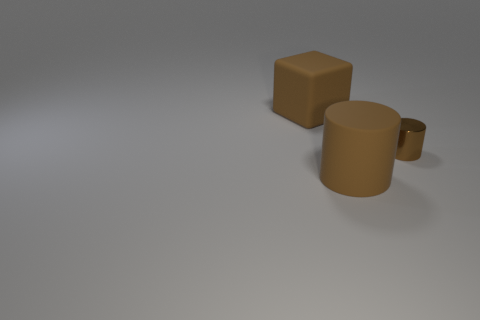Add 1 big cylinders. How many objects exist? 4 Subtract all blocks. How many objects are left? 2 Add 3 small metal things. How many small metal things are left? 4 Add 1 tiny cyan spheres. How many tiny cyan spheres exist? 1 Subtract 0 yellow cylinders. How many objects are left? 3 Subtract all brown cylinders. Subtract all big matte cylinders. How many objects are left? 0 